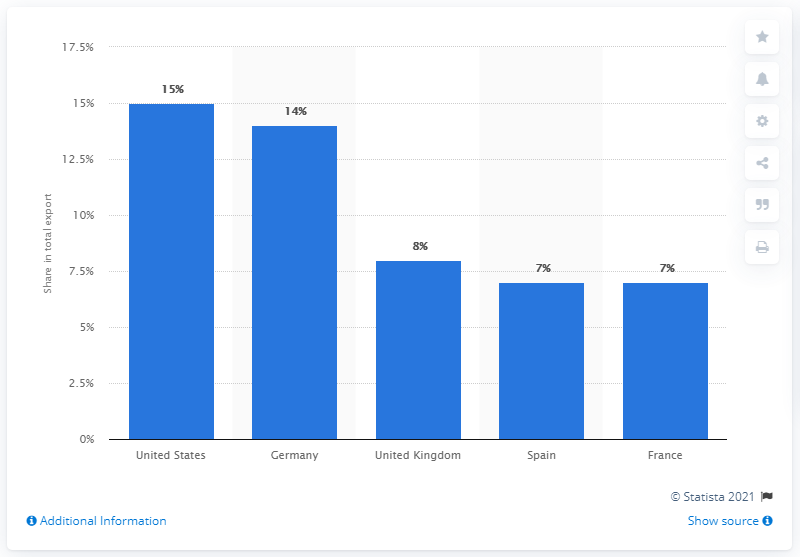Draw attention to some important aspects in this diagram. In 2019, the United States was Bangladesh's most important export partner, accounting for a significant portion of its global exports. In 2019, the United States was Bangladesh's most important export partner. 